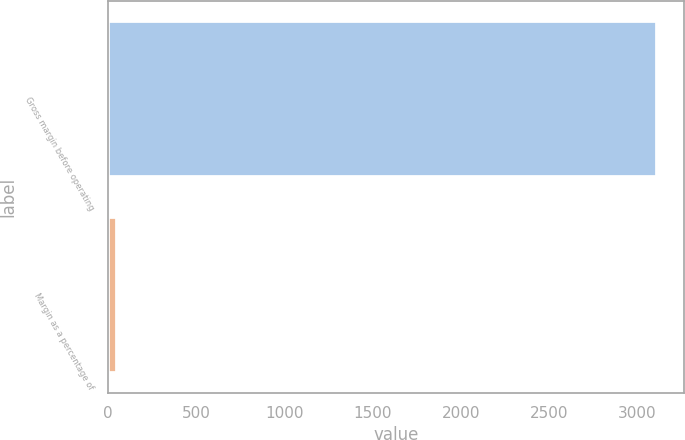Convert chart to OTSL. <chart><loc_0><loc_0><loc_500><loc_500><bar_chart><fcel>Gross margin before operating<fcel>Margin as a percentage of<nl><fcel>3109<fcel>51.6<nl></chart> 